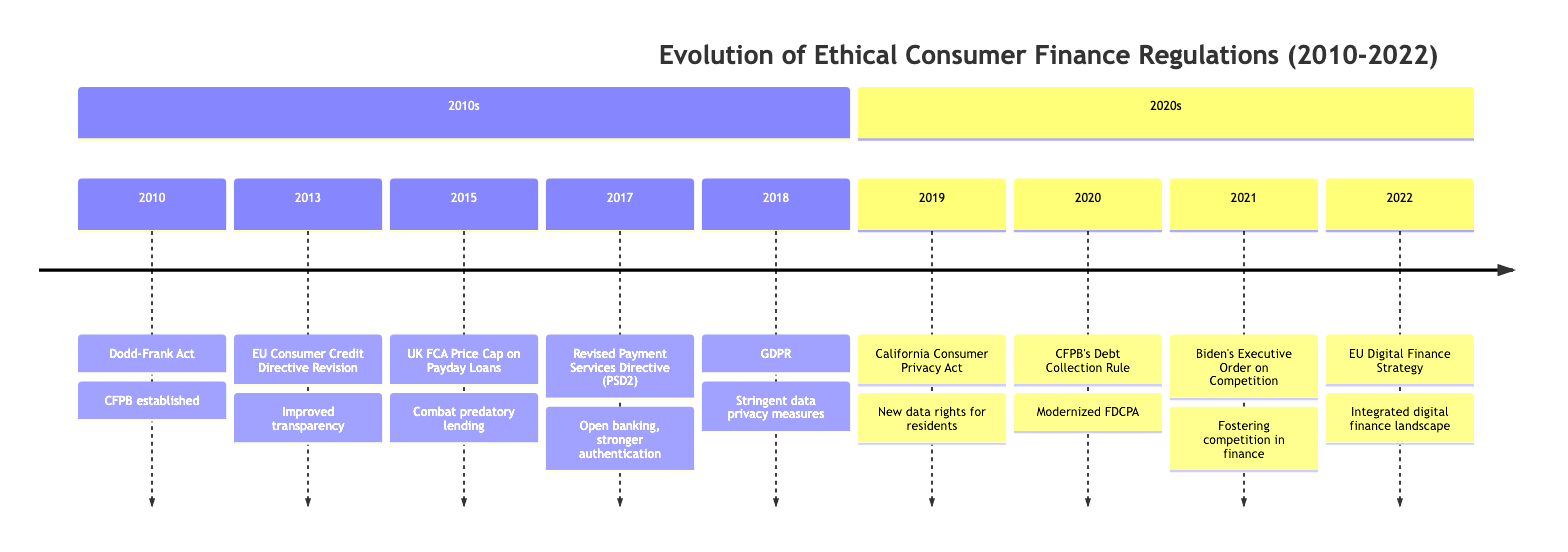What year was the Dodd-Frank Act enacted? The Dodd-Frank Act is listed as the first event in the timeline, which clearly states it was enacted in 2010.
Answer: 2010 What does the UK FCA's 2015 regulation address? The event from 2015 mentions that the UK FCA introduced a price cap on payday loans to combat predatory lending practices, which specifies what issue it addresses.
Answer: Predatory lending What year did the CCPA come into effect? According to the timeline, the California Consumer Privacy Act was enacted in 2019, and it is explicitly stated with the year associated with the event.
Answer: 2019 Which legislation focused on digital privacy in 2018? The timeline highlights the General Data Protection Regulation (GDPR) as the event in the year 2018, which directly relates to digital privacy.
Answer: GDPR Which event aimed to promote competition in the American economy? The timeline indicates that in 2021, the Biden Administration's Executive Order on Promoting Competition was the event that aimed to foster competition, leading to its identification in the timeline.
Answer: Biden's Executive Order on Competition What two regulations were established in the 2010s that specifically aimed at consumer protection? To find the answer, we need to gather information on the events that focus on consumer protection from the timeline: the Dodd-Frank Act (2010) and the UK FCA's price cap on payday loans (2015). Both explicitly mention consumer protection.
Answer: Dodd-Frank Act, FCA price cap What is the main goal of the EU Digital Finance Strategy adopted in 2022? The last event mentioned for 2022 states that the EU Digital Finance Strategy aimed to create an integrated digital finance landscape while maintaining robust consumer protections, summarizing its main goal.
Answer: Integrated digital finance landscape How many key regulations were introduced in the 2020s according to the timeline? By counting the events listed in the "2020s" section of the timeline, we find four distinct regulations: CCPA, CFPB's Debt Collection Rule, Biden's Executive Order on Competition, and EU Digital Finance Strategy.
Answer: 4 What major consumer regulation was updated in 2020? The timeline specifies that the CFPB's Debt Collection Rule was the major consumer regulation updated in 2020, highlighting the key focus for that year.
Answer: CFPB's Debt Collection Rule 